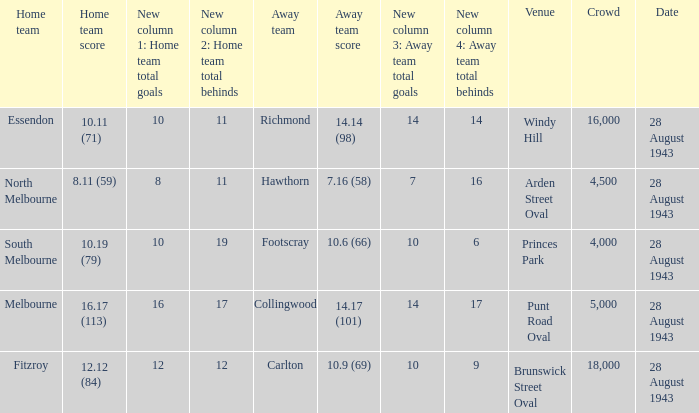17 (101)? Punt Road Oval. 